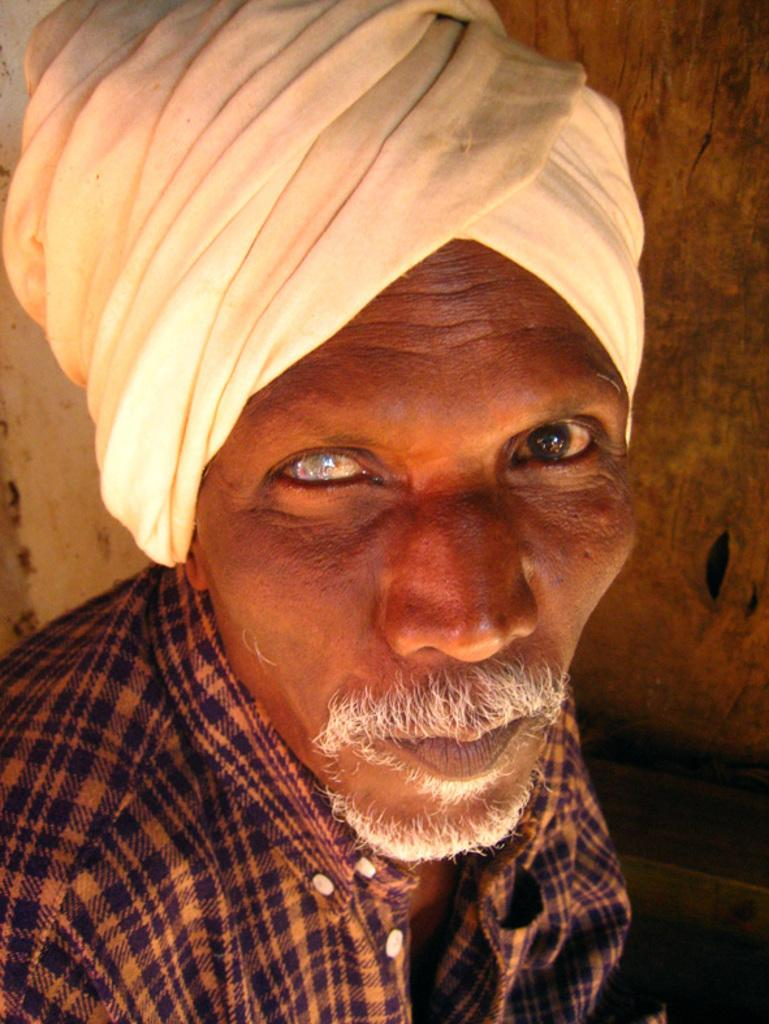Who is the main subject in the image? There is an old man in the image. What is the old man wearing on his head? The old man is wearing a white turban. What can be seen in the background of the image? There is a wall in the background of the image. Can you tell me how many snakes are slithering on the edge of the wall in the image? There are no snakes present in the image, and therefore no such activity can be observed. 